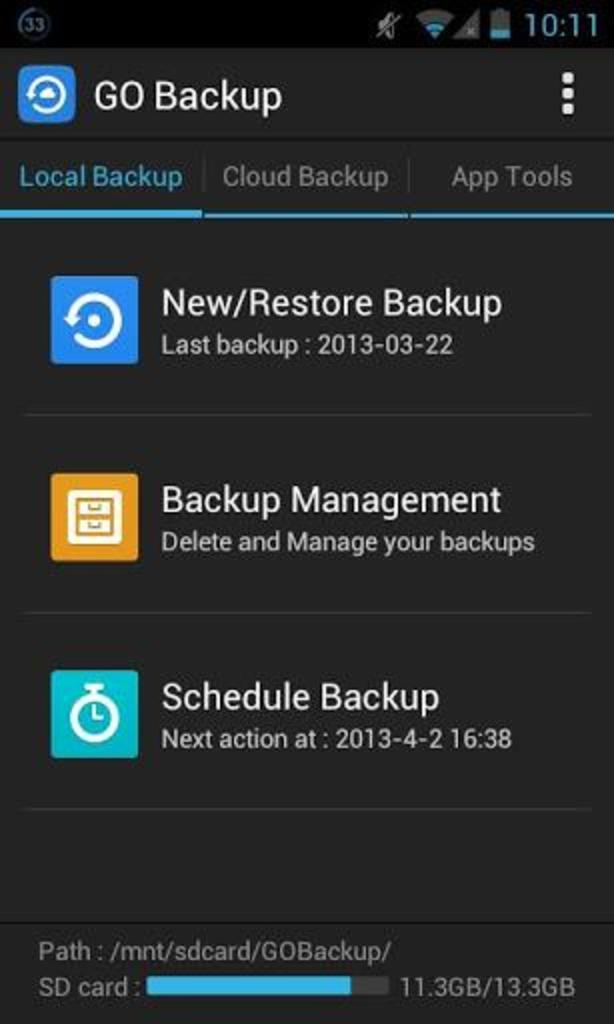What type of image is shown in the screenshot? The image contains a screenshot of mobile settings. What type of car is visible in the image? There is no car present in the image; it features a screenshot of mobile settings. How does the action of improving health relate to the image? The image does not depict any actions related to health; it is a screenshot of mobile settings. 